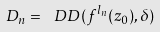Convert formula to latex. <formula><loc_0><loc_0><loc_500><loc_500>D _ { n } = \ D D ( f ^ { l _ { n } } ( z _ { 0 } ) , \delta )</formula> 